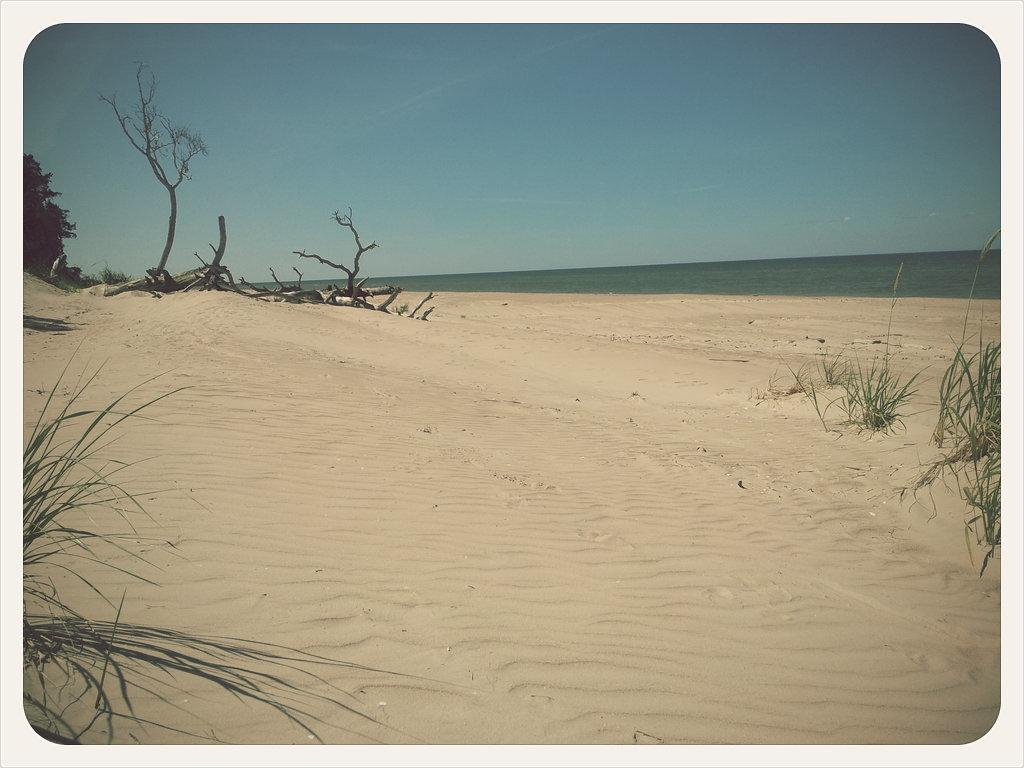What type of terrain is visible in the image? The image contains sandy land. What type of vegetation can be seen on the sandy land? There is grass on the sandy land. What type of trees are present in the image? There are dry trees in the image. What body of water is visible in the image? There is a sea in the middle of the image. What is the color of the sky in the image? The sky is blue in color. What type of silk fabric is draped over the box in the image? There is no box or silk fabric present in the image. 